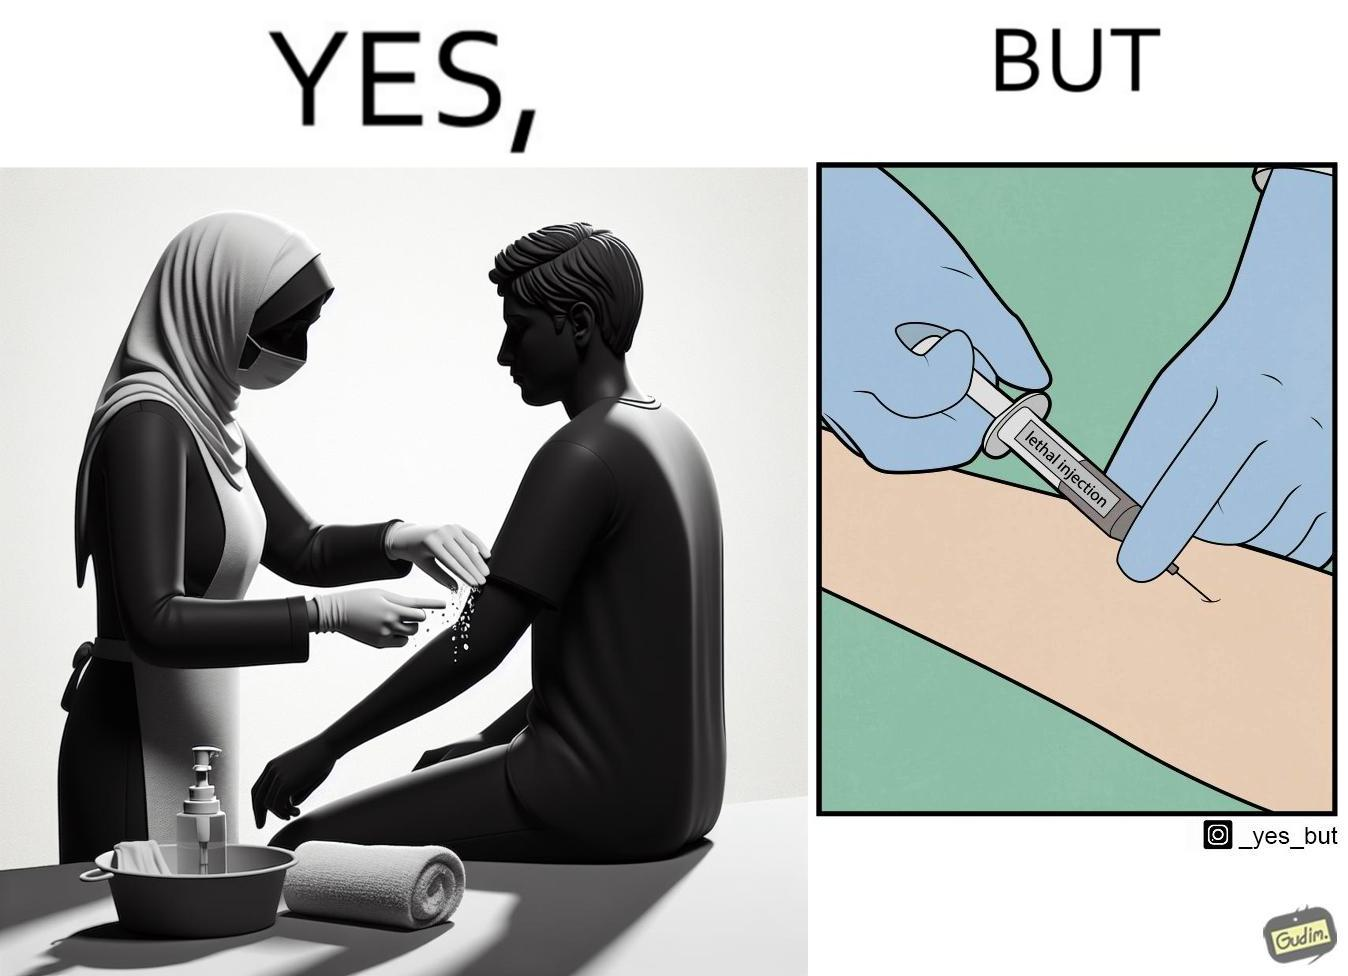Describe the content of this image. The image is ironical, as rubbing alcohol is used to clean a place on the arm for giving an injection, while the injection itself is 'lethal'. 